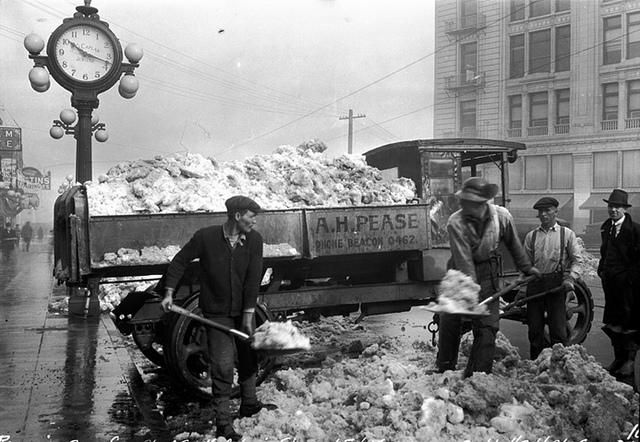What does this vehicle hold in it's rear? Please explain your reasoning. snow. There are men shoveling a white, thick, dirty substance off the street into the bed of the truck. 